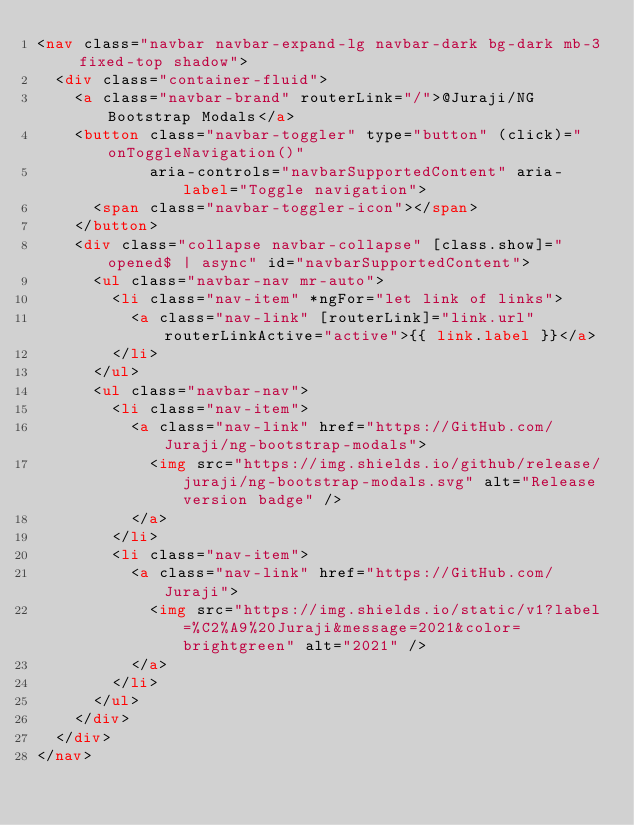Convert code to text. <code><loc_0><loc_0><loc_500><loc_500><_HTML_><nav class="navbar navbar-expand-lg navbar-dark bg-dark mb-3 fixed-top shadow">
  <div class="container-fluid">
    <a class="navbar-brand" routerLink="/">@Juraji/NG Bootstrap Modals</a>
    <button class="navbar-toggler" type="button" (click)="onToggleNavigation()"
            aria-controls="navbarSupportedContent" aria-label="Toggle navigation">
      <span class="navbar-toggler-icon"></span>
    </button>
    <div class="collapse navbar-collapse" [class.show]="opened$ | async" id="navbarSupportedContent">
      <ul class="navbar-nav mr-auto">
        <li class="nav-item" *ngFor="let link of links">
          <a class="nav-link" [routerLink]="link.url" routerLinkActive="active">{{ link.label }}</a>
        </li>
      </ul>
      <ul class="navbar-nav">
        <li class="nav-item">
          <a class="nav-link" href="https://GitHub.com/Juraji/ng-bootstrap-modals">
            <img src="https://img.shields.io/github/release/juraji/ng-bootstrap-modals.svg" alt="Release version badge" />
          </a>
        </li>
        <li class="nav-item">
          <a class="nav-link" href="https://GitHub.com/Juraji">
            <img src="https://img.shields.io/static/v1?label=%C2%A9%20Juraji&message=2021&color=brightgreen" alt="2021" />
          </a>
        </li>
      </ul>
    </div>
  </div>
</nav>
</code> 